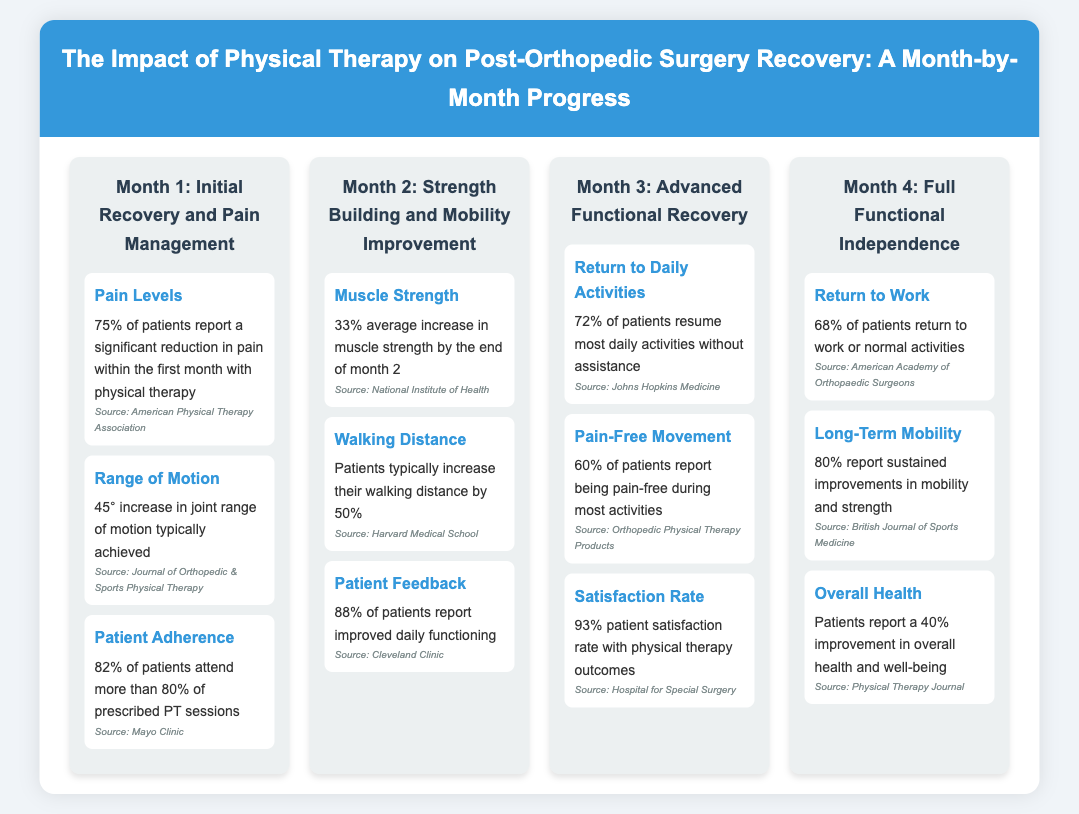What percentage of patients report a significant reduction in pain within the first month? The document states that 75% of patients report a significant reduction in pain within the first month.
Answer: 75% What is the average increase in muscle strength by the end of month 2? According to the document, there is a 33% average increase in muscle strength by the end of month 2.
Answer: 33% How many patients report being pain-free during most activities by month 3? The infographic indicates that 60% of patients report being pain-free during most activities by month 3.
Answer: 60% What percentage of patients return to work or normal activities by month 4? The document specifies that 68% of patients return to work or normal activities by month 4.
Answer: 68% What is the patient satisfaction rate with physical therapy outcomes? The infographic reveals that there is a 93% patient satisfaction rate with physical therapy outcomes.
Answer: 93% What are patients' reports of overall health improvement by the end of month 4? The document notes that patients report a 40% improvement in overall health and well-being by the end of month 4.
Answer: 40% Which month shows an increase in walking distance by 50%? The infographic indicates that walking distance increases by 50% in month 2.
Answer: Month 2 Which source reported the 45° increase in joint range of motion during the first month? The source reporting the 45° increase in joint range of motion is the Journal of Orthopedic & Sports Physical Therapy.
Answer: Journal of Orthopedic & Sports Physical Therapy In which month do patients typically resume most daily activities without assistance? The document states that patients typically resume most daily activities without assistance in month 3.
Answer: Month 3 